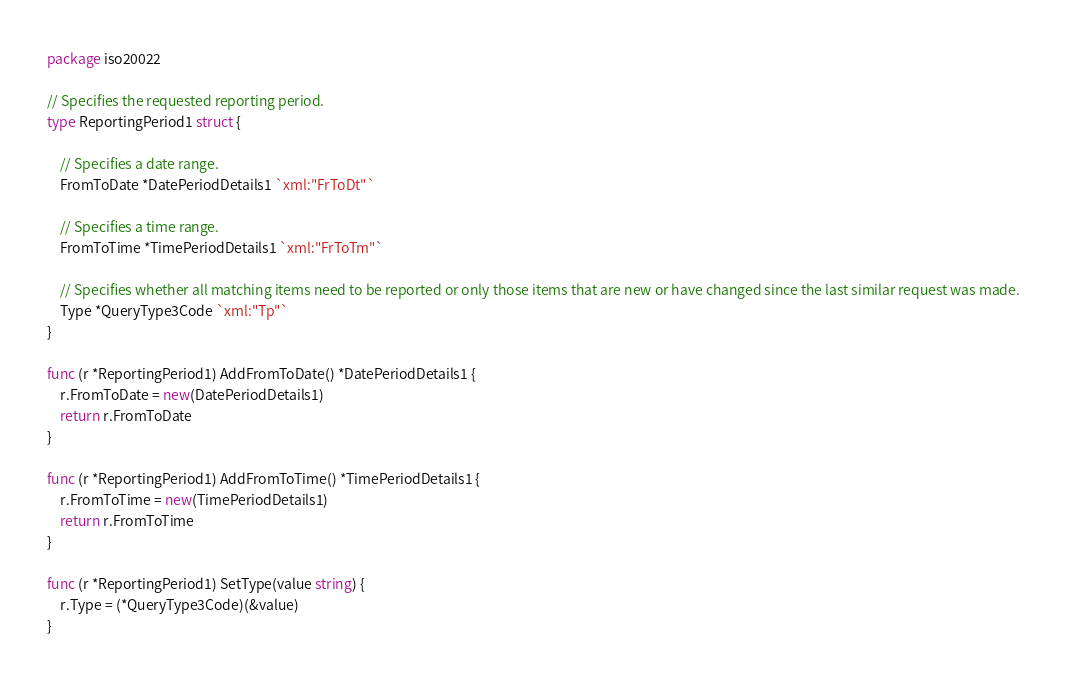<code> <loc_0><loc_0><loc_500><loc_500><_Go_>package iso20022

// Specifies the requested reporting period.
type ReportingPeriod1 struct {

	// Specifies a date range.
	FromToDate *DatePeriodDetails1 `xml:"FrToDt"`

	// Specifies a time range.
	FromToTime *TimePeriodDetails1 `xml:"FrToTm"`

	// Specifies whether all matching items need to be reported or only those items that are new or have changed since the last similar request was made.
	Type *QueryType3Code `xml:"Tp"`
}

func (r *ReportingPeriod1) AddFromToDate() *DatePeriodDetails1 {
	r.FromToDate = new(DatePeriodDetails1)
	return r.FromToDate
}

func (r *ReportingPeriod1) AddFromToTime() *TimePeriodDetails1 {
	r.FromToTime = new(TimePeriodDetails1)
	return r.FromToTime
}

func (r *ReportingPeriod1) SetType(value string) {
	r.Type = (*QueryType3Code)(&value)
}
</code> 